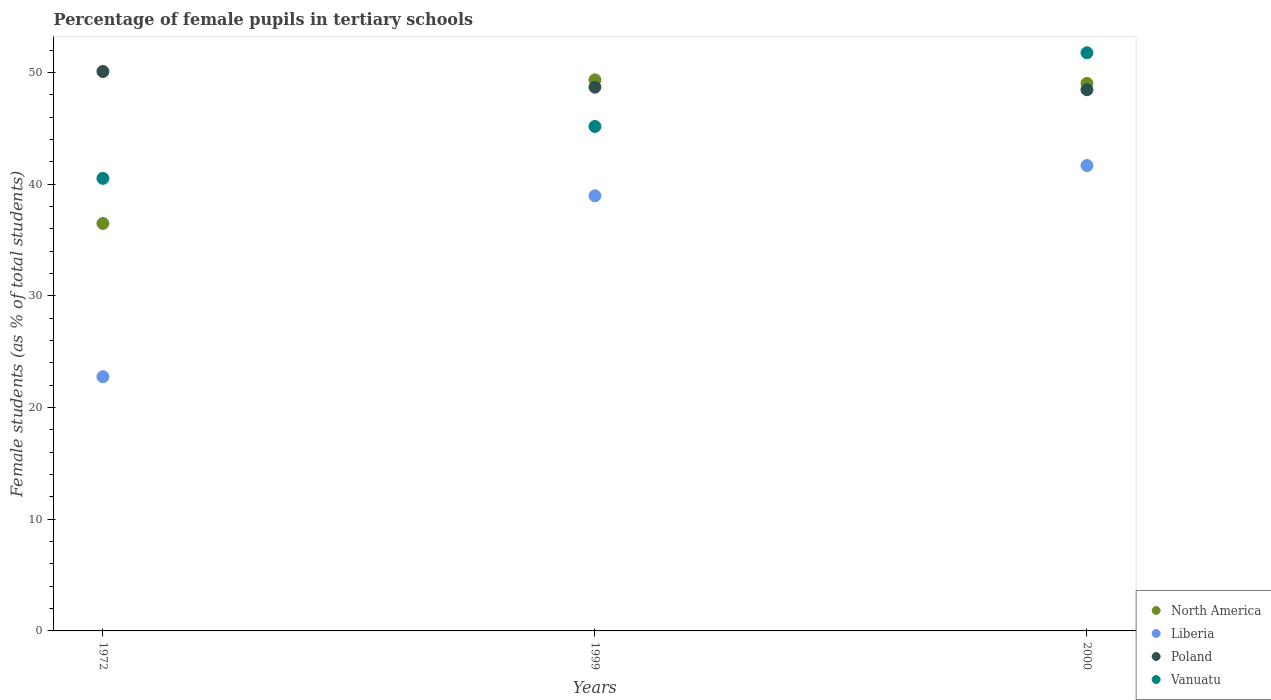How many different coloured dotlines are there?
Your answer should be very brief. 4. Is the number of dotlines equal to the number of legend labels?
Your answer should be compact. Yes. What is the percentage of female pupils in tertiary schools in Poland in 1972?
Keep it short and to the point. 50.08. Across all years, what is the maximum percentage of female pupils in tertiary schools in North America?
Give a very brief answer. 49.33. Across all years, what is the minimum percentage of female pupils in tertiary schools in Vanuatu?
Offer a very short reply. 40.51. In which year was the percentage of female pupils in tertiary schools in North America minimum?
Offer a very short reply. 1972. What is the total percentage of female pupils in tertiary schools in Liberia in the graph?
Keep it short and to the point. 103.36. What is the difference between the percentage of female pupils in tertiary schools in Vanuatu in 1999 and that in 2000?
Provide a succinct answer. -6.6. What is the difference between the percentage of female pupils in tertiary schools in North America in 1999 and the percentage of female pupils in tertiary schools in Poland in 2000?
Offer a terse response. 0.88. What is the average percentage of female pupils in tertiary schools in North America per year?
Your answer should be compact. 44.94. In the year 1972, what is the difference between the percentage of female pupils in tertiary schools in Vanuatu and percentage of female pupils in tertiary schools in North America?
Provide a short and direct response. 4.04. In how many years, is the percentage of female pupils in tertiary schools in Poland greater than 16 %?
Your answer should be compact. 3. What is the ratio of the percentage of female pupils in tertiary schools in Vanuatu in 1972 to that in 2000?
Your response must be concise. 0.78. Is the percentage of female pupils in tertiary schools in North America in 1972 less than that in 1999?
Provide a succinct answer. Yes. Is the difference between the percentage of female pupils in tertiary schools in Vanuatu in 1999 and 2000 greater than the difference between the percentage of female pupils in tertiary schools in North America in 1999 and 2000?
Make the answer very short. No. What is the difference between the highest and the second highest percentage of female pupils in tertiary schools in Vanuatu?
Provide a short and direct response. 6.6. What is the difference between the highest and the lowest percentage of female pupils in tertiary schools in Liberia?
Give a very brief answer. 18.9. In how many years, is the percentage of female pupils in tertiary schools in Vanuatu greater than the average percentage of female pupils in tertiary schools in Vanuatu taken over all years?
Your answer should be very brief. 1. Is it the case that in every year, the sum of the percentage of female pupils in tertiary schools in Poland and percentage of female pupils in tertiary schools in Liberia  is greater than the sum of percentage of female pupils in tertiary schools in North America and percentage of female pupils in tertiary schools in Vanuatu?
Offer a terse response. No. Is it the case that in every year, the sum of the percentage of female pupils in tertiary schools in Liberia and percentage of female pupils in tertiary schools in North America  is greater than the percentage of female pupils in tertiary schools in Vanuatu?
Provide a short and direct response. Yes. Is the percentage of female pupils in tertiary schools in Vanuatu strictly greater than the percentage of female pupils in tertiary schools in Liberia over the years?
Your answer should be compact. Yes. How many dotlines are there?
Provide a succinct answer. 4. How many years are there in the graph?
Offer a very short reply. 3. Does the graph contain any zero values?
Your answer should be very brief. No. Where does the legend appear in the graph?
Provide a succinct answer. Bottom right. What is the title of the graph?
Offer a very short reply. Percentage of female pupils in tertiary schools. What is the label or title of the Y-axis?
Provide a short and direct response. Female students (as % of total students). What is the Female students (as % of total students) in North America in 1972?
Keep it short and to the point. 36.47. What is the Female students (as % of total students) of Liberia in 1972?
Ensure brevity in your answer.  22.75. What is the Female students (as % of total students) in Poland in 1972?
Make the answer very short. 50.08. What is the Female students (as % of total students) in Vanuatu in 1972?
Make the answer very short. 40.51. What is the Female students (as % of total students) in North America in 1999?
Your response must be concise. 49.33. What is the Female students (as % of total students) in Liberia in 1999?
Make the answer very short. 38.95. What is the Female students (as % of total students) of Poland in 1999?
Give a very brief answer. 48.67. What is the Female students (as % of total students) of Vanuatu in 1999?
Your answer should be very brief. 45.16. What is the Female students (as % of total students) of North America in 2000?
Offer a terse response. 49.01. What is the Female students (as % of total students) in Liberia in 2000?
Provide a succinct answer. 41.66. What is the Female students (as % of total students) of Poland in 2000?
Ensure brevity in your answer.  48.44. What is the Female students (as % of total students) of Vanuatu in 2000?
Provide a short and direct response. 51.75. Across all years, what is the maximum Female students (as % of total students) in North America?
Make the answer very short. 49.33. Across all years, what is the maximum Female students (as % of total students) of Liberia?
Your answer should be compact. 41.66. Across all years, what is the maximum Female students (as % of total students) in Poland?
Provide a short and direct response. 50.08. Across all years, what is the maximum Female students (as % of total students) in Vanuatu?
Provide a succinct answer. 51.75. Across all years, what is the minimum Female students (as % of total students) in North America?
Your response must be concise. 36.47. Across all years, what is the minimum Female students (as % of total students) in Liberia?
Your answer should be compact. 22.75. Across all years, what is the minimum Female students (as % of total students) of Poland?
Your answer should be very brief. 48.44. Across all years, what is the minimum Female students (as % of total students) in Vanuatu?
Offer a very short reply. 40.51. What is the total Female students (as % of total students) of North America in the graph?
Your answer should be very brief. 134.81. What is the total Female students (as % of total students) in Liberia in the graph?
Your answer should be very brief. 103.36. What is the total Female students (as % of total students) in Poland in the graph?
Ensure brevity in your answer.  147.19. What is the total Female students (as % of total students) in Vanuatu in the graph?
Your answer should be very brief. 137.42. What is the difference between the Female students (as % of total students) of North America in 1972 and that in 1999?
Offer a very short reply. -12.85. What is the difference between the Female students (as % of total students) of Liberia in 1972 and that in 1999?
Provide a succinct answer. -16.2. What is the difference between the Female students (as % of total students) of Poland in 1972 and that in 1999?
Offer a terse response. 1.4. What is the difference between the Female students (as % of total students) in Vanuatu in 1972 and that in 1999?
Offer a terse response. -4.64. What is the difference between the Female students (as % of total students) in North America in 1972 and that in 2000?
Give a very brief answer. -12.54. What is the difference between the Female students (as % of total students) of Liberia in 1972 and that in 2000?
Keep it short and to the point. -18.9. What is the difference between the Female students (as % of total students) of Poland in 1972 and that in 2000?
Make the answer very short. 1.63. What is the difference between the Female students (as % of total students) of Vanuatu in 1972 and that in 2000?
Your answer should be very brief. -11.24. What is the difference between the Female students (as % of total students) in North America in 1999 and that in 2000?
Give a very brief answer. 0.32. What is the difference between the Female students (as % of total students) in Liberia in 1999 and that in 2000?
Give a very brief answer. -2.71. What is the difference between the Female students (as % of total students) in Poland in 1999 and that in 2000?
Your response must be concise. 0.23. What is the difference between the Female students (as % of total students) in Vanuatu in 1999 and that in 2000?
Offer a very short reply. -6.6. What is the difference between the Female students (as % of total students) in North America in 1972 and the Female students (as % of total students) in Liberia in 1999?
Offer a terse response. -2.48. What is the difference between the Female students (as % of total students) in North America in 1972 and the Female students (as % of total students) in Poland in 1999?
Offer a very short reply. -12.2. What is the difference between the Female students (as % of total students) of North America in 1972 and the Female students (as % of total students) of Vanuatu in 1999?
Provide a short and direct response. -8.68. What is the difference between the Female students (as % of total students) of Liberia in 1972 and the Female students (as % of total students) of Poland in 1999?
Ensure brevity in your answer.  -25.92. What is the difference between the Female students (as % of total students) in Liberia in 1972 and the Female students (as % of total students) in Vanuatu in 1999?
Provide a short and direct response. -22.4. What is the difference between the Female students (as % of total students) of Poland in 1972 and the Female students (as % of total students) of Vanuatu in 1999?
Offer a very short reply. 4.92. What is the difference between the Female students (as % of total students) of North America in 1972 and the Female students (as % of total students) of Liberia in 2000?
Offer a terse response. -5.18. What is the difference between the Female students (as % of total students) in North America in 1972 and the Female students (as % of total students) in Poland in 2000?
Ensure brevity in your answer.  -11.97. What is the difference between the Female students (as % of total students) in North America in 1972 and the Female students (as % of total students) in Vanuatu in 2000?
Provide a short and direct response. -15.28. What is the difference between the Female students (as % of total students) in Liberia in 1972 and the Female students (as % of total students) in Poland in 2000?
Ensure brevity in your answer.  -25.69. What is the difference between the Female students (as % of total students) of Liberia in 1972 and the Female students (as % of total students) of Vanuatu in 2000?
Provide a short and direct response. -29. What is the difference between the Female students (as % of total students) in Poland in 1972 and the Female students (as % of total students) in Vanuatu in 2000?
Offer a very short reply. -1.68. What is the difference between the Female students (as % of total students) of North America in 1999 and the Female students (as % of total students) of Liberia in 2000?
Provide a succinct answer. 7.67. What is the difference between the Female students (as % of total students) of North America in 1999 and the Female students (as % of total students) of Poland in 2000?
Make the answer very short. 0.88. What is the difference between the Female students (as % of total students) of North America in 1999 and the Female students (as % of total students) of Vanuatu in 2000?
Make the answer very short. -2.42. What is the difference between the Female students (as % of total students) of Liberia in 1999 and the Female students (as % of total students) of Poland in 2000?
Your response must be concise. -9.49. What is the difference between the Female students (as % of total students) of Liberia in 1999 and the Female students (as % of total students) of Vanuatu in 2000?
Offer a very short reply. -12.8. What is the difference between the Female students (as % of total students) of Poland in 1999 and the Female students (as % of total students) of Vanuatu in 2000?
Your answer should be very brief. -3.08. What is the average Female students (as % of total students) of North America per year?
Your answer should be very brief. 44.94. What is the average Female students (as % of total students) in Liberia per year?
Make the answer very short. 34.45. What is the average Female students (as % of total students) in Poland per year?
Offer a terse response. 49.06. What is the average Female students (as % of total students) in Vanuatu per year?
Keep it short and to the point. 45.81. In the year 1972, what is the difference between the Female students (as % of total students) of North America and Female students (as % of total students) of Liberia?
Provide a succinct answer. 13.72. In the year 1972, what is the difference between the Female students (as % of total students) of North America and Female students (as % of total students) of Poland?
Give a very brief answer. -13.6. In the year 1972, what is the difference between the Female students (as % of total students) in North America and Female students (as % of total students) in Vanuatu?
Keep it short and to the point. -4.04. In the year 1972, what is the difference between the Female students (as % of total students) in Liberia and Female students (as % of total students) in Poland?
Provide a short and direct response. -27.32. In the year 1972, what is the difference between the Female students (as % of total students) in Liberia and Female students (as % of total students) in Vanuatu?
Offer a terse response. -17.76. In the year 1972, what is the difference between the Female students (as % of total students) of Poland and Female students (as % of total students) of Vanuatu?
Make the answer very short. 9.57. In the year 1999, what is the difference between the Female students (as % of total students) of North America and Female students (as % of total students) of Liberia?
Keep it short and to the point. 10.38. In the year 1999, what is the difference between the Female students (as % of total students) of North America and Female students (as % of total students) of Poland?
Your answer should be very brief. 0.66. In the year 1999, what is the difference between the Female students (as % of total students) of North America and Female students (as % of total students) of Vanuatu?
Your answer should be very brief. 4.17. In the year 1999, what is the difference between the Female students (as % of total students) in Liberia and Female students (as % of total students) in Poland?
Give a very brief answer. -9.72. In the year 1999, what is the difference between the Female students (as % of total students) in Liberia and Female students (as % of total students) in Vanuatu?
Provide a succinct answer. -6.21. In the year 1999, what is the difference between the Female students (as % of total students) of Poland and Female students (as % of total students) of Vanuatu?
Make the answer very short. 3.52. In the year 2000, what is the difference between the Female students (as % of total students) of North America and Female students (as % of total students) of Liberia?
Give a very brief answer. 7.35. In the year 2000, what is the difference between the Female students (as % of total students) in North America and Female students (as % of total students) in Poland?
Provide a short and direct response. 0.57. In the year 2000, what is the difference between the Female students (as % of total students) of North America and Female students (as % of total students) of Vanuatu?
Keep it short and to the point. -2.74. In the year 2000, what is the difference between the Female students (as % of total students) of Liberia and Female students (as % of total students) of Poland?
Provide a succinct answer. -6.79. In the year 2000, what is the difference between the Female students (as % of total students) in Liberia and Female students (as % of total students) in Vanuatu?
Your answer should be compact. -10.09. In the year 2000, what is the difference between the Female students (as % of total students) of Poland and Female students (as % of total students) of Vanuatu?
Your answer should be very brief. -3.31. What is the ratio of the Female students (as % of total students) in North America in 1972 to that in 1999?
Offer a terse response. 0.74. What is the ratio of the Female students (as % of total students) of Liberia in 1972 to that in 1999?
Your answer should be very brief. 0.58. What is the ratio of the Female students (as % of total students) of Poland in 1972 to that in 1999?
Provide a succinct answer. 1.03. What is the ratio of the Female students (as % of total students) of Vanuatu in 1972 to that in 1999?
Keep it short and to the point. 0.9. What is the ratio of the Female students (as % of total students) of North America in 1972 to that in 2000?
Keep it short and to the point. 0.74. What is the ratio of the Female students (as % of total students) of Liberia in 1972 to that in 2000?
Provide a succinct answer. 0.55. What is the ratio of the Female students (as % of total students) in Poland in 1972 to that in 2000?
Provide a succinct answer. 1.03. What is the ratio of the Female students (as % of total students) in Vanuatu in 1972 to that in 2000?
Offer a terse response. 0.78. What is the ratio of the Female students (as % of total students) in Liberia in 1999 to that in 2000?
Your response must be concise. 0.94. What is the ratio of the Female students (as % of total students) in Poland in 1999 to that in 2000?
Make the answer very short. 1. What is the ratio of the Female students (as % of total students) in Vanuatu in 1999 to that in 2000?
Your answer should be very brief. 0.87. What is the difference between the highest and the second highest Female students (as % of total students) in North America?
Offer a terse response. 0.32. What is the difference between the highest and the second highest Female students (as % of total students) in Liberia?
Your answer should be very brief. 2.71. What is the difference between the highest and the second highest Female students (as % of total students) of Poland?
Offer a very short reply. 1.4. What is the difference between the highest and the second highest Female students (as % of total students) of Vanuatu?
Give a very brief answer. 6.6. What is the difference between the highest and the lowest Female students (as % of total students) in North America?
Provide a short and direct response. 12.85. What is the difference between the highest and the lowest Female students (as % of total students) in Liberia?
Your response must be concise. 18.9. What is the difference between the highest and the lowest Female students (as % of total students) of Poland?
Make the answer very short. 1.63. What is the difference between the highest and the lowest Female students (as % of total students) of Vanuatu?
Your answer should be very brief. 11.24. 